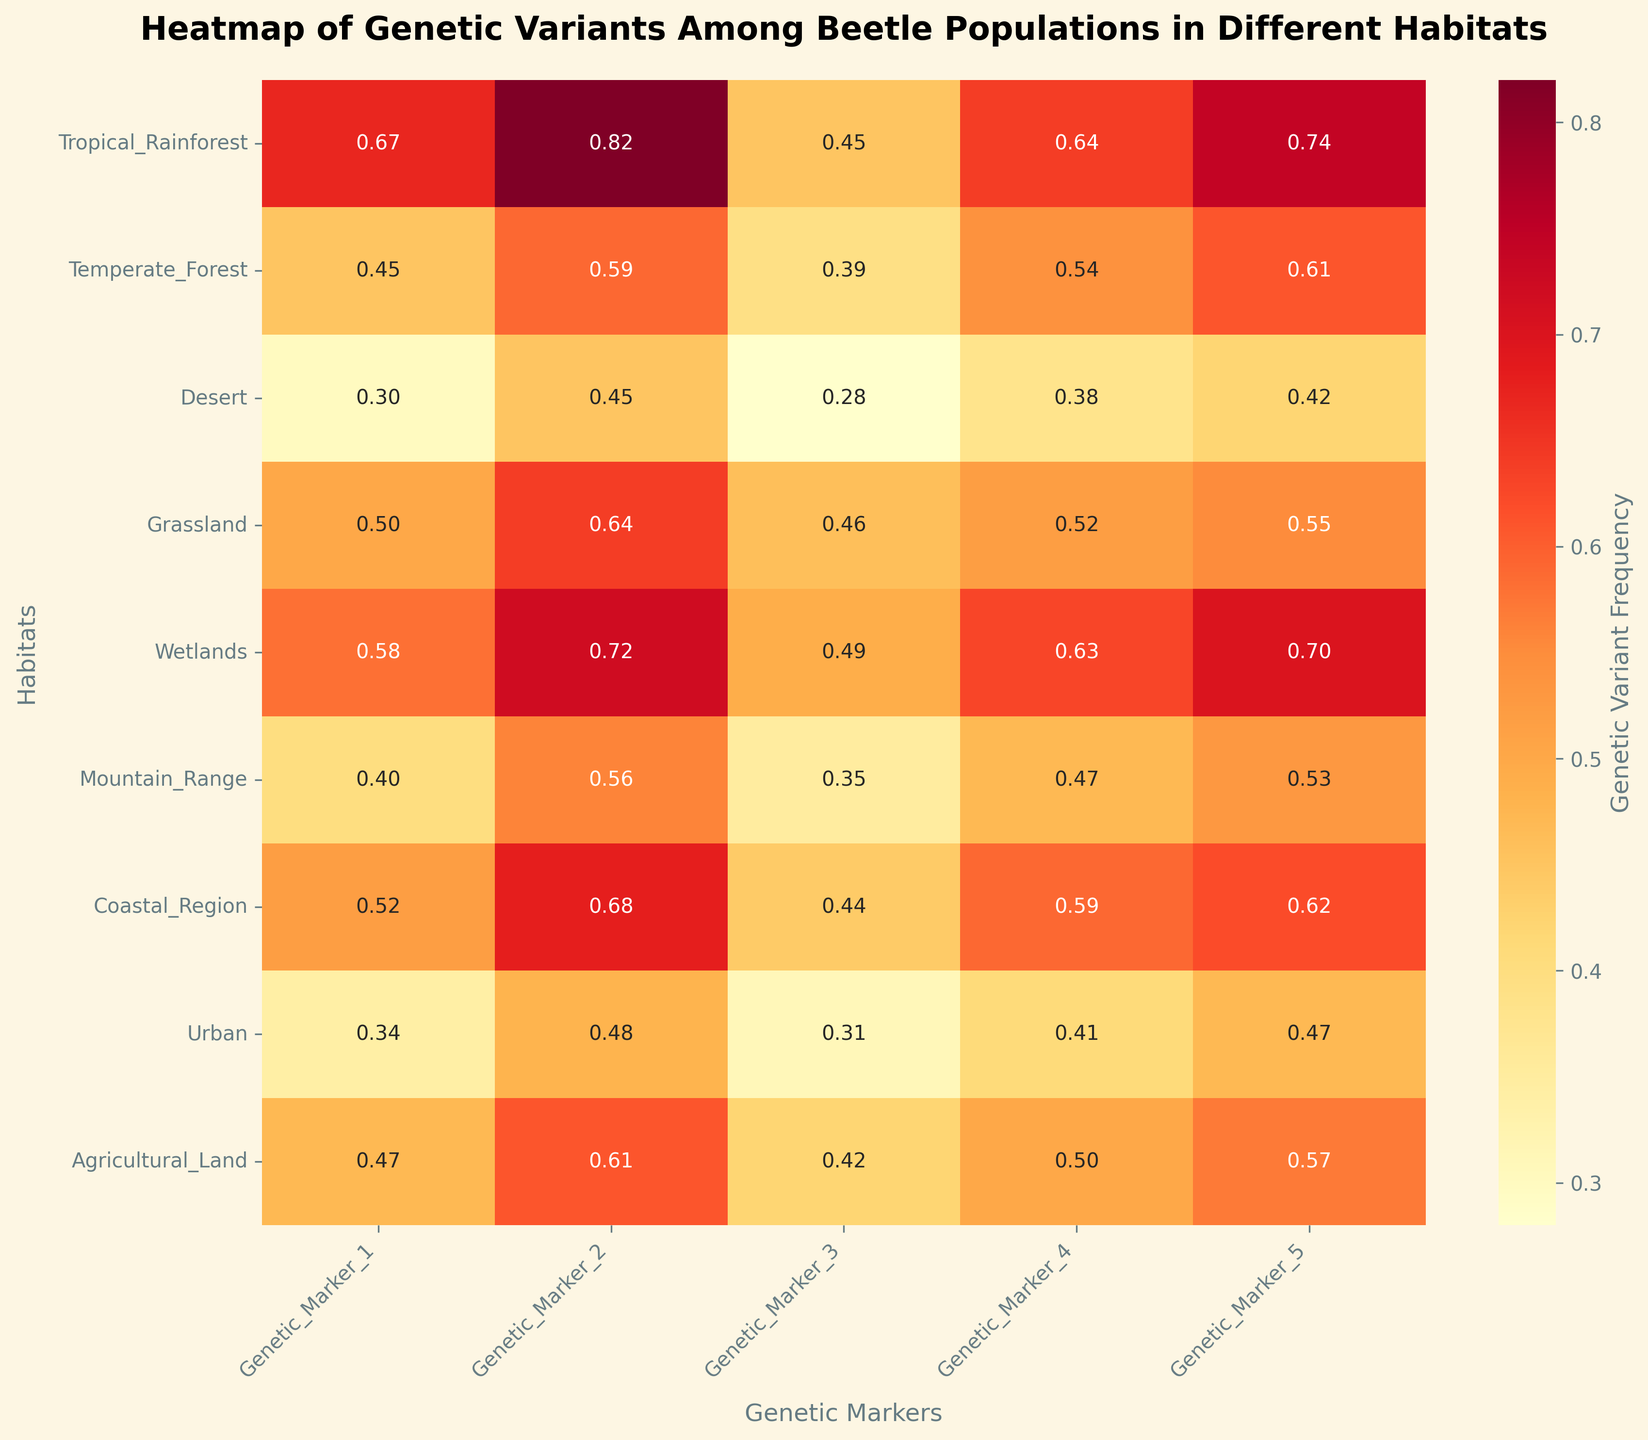What is the title of the heatmap? The title is located at the top of the figure and provides a clear description of what the heatmap represents.
Answer: Heatmap of Genetic Variants Among Beetle Populations in Different Habitats How many habitats are compared in the heatmap? Count the number of unique habitats listed on the y-axis. There are 9 different habitats shown.
Answer: 9 Which habitat has the lowest genetic variant frequency for Genetic Marker 3? Identify the cell in the Genetic Marker 3 column with the lowest value. The Urban habitat shows the lowest frequency at 0.31.
Answer: Urban What is the average frequency of Genetic Marker 2 across all habitats? Sum the frequencies of Genetic Marker 2 across all habitats and divide by the total number of habitats: (0.82 + 0.59 + 0.45 + 0.64 + 0.72 + 0.56 + 0.68 + 0.48 + 0.61) / 9 = 0.61
Answer: 0.61 Comparing Tropical Rainforest and Desert, which habitat has a higher frequency for Genetic Marker 1 and by how much? Identify the values for Genetic Marker 1 in both habitats (0.67 for Tropical Rainforest and 0.30 for Desert), then find the difference: 0.67 - 0.30 = 0.37
Answer: Tropical Rainforest, 0.37 Which genetic marker shows the highest frequency in the Coastal Region habitat? Look across the row for Coastal_Region to find the maximum value. Genetic Marker 2 shows the highest frequency at 0.68.
Answer: Genetic Marker 2 What is the overall range of frequencies for the Mountain Range habitat? Identify the minimum and maximum frequencies for Mountain Range, then calculate the range: max(0.56) - min(0.35) = 0.21
Answer: 0.21 How does the frequency of Genetic Marker 5 in Agricultural Land compare to that in Temperate Forest? Identify the values for Genetic Marker 5 in both habitats (0.57 for Agricultural Land and 0.61 for Temperate Forest), and determine which is higher and by how much: 0.61 - 0.57 = 0.04
Answer: Temperate Forest, 0.04 Which genetic marker has the least variation in frequency across all habitats? Calculate the range (max - min) for each genetic marker and identify the smallest range: Genetic Marker 4 (0.63 - 0.38 = 0.25).
Answer: Genetic Marker 4 